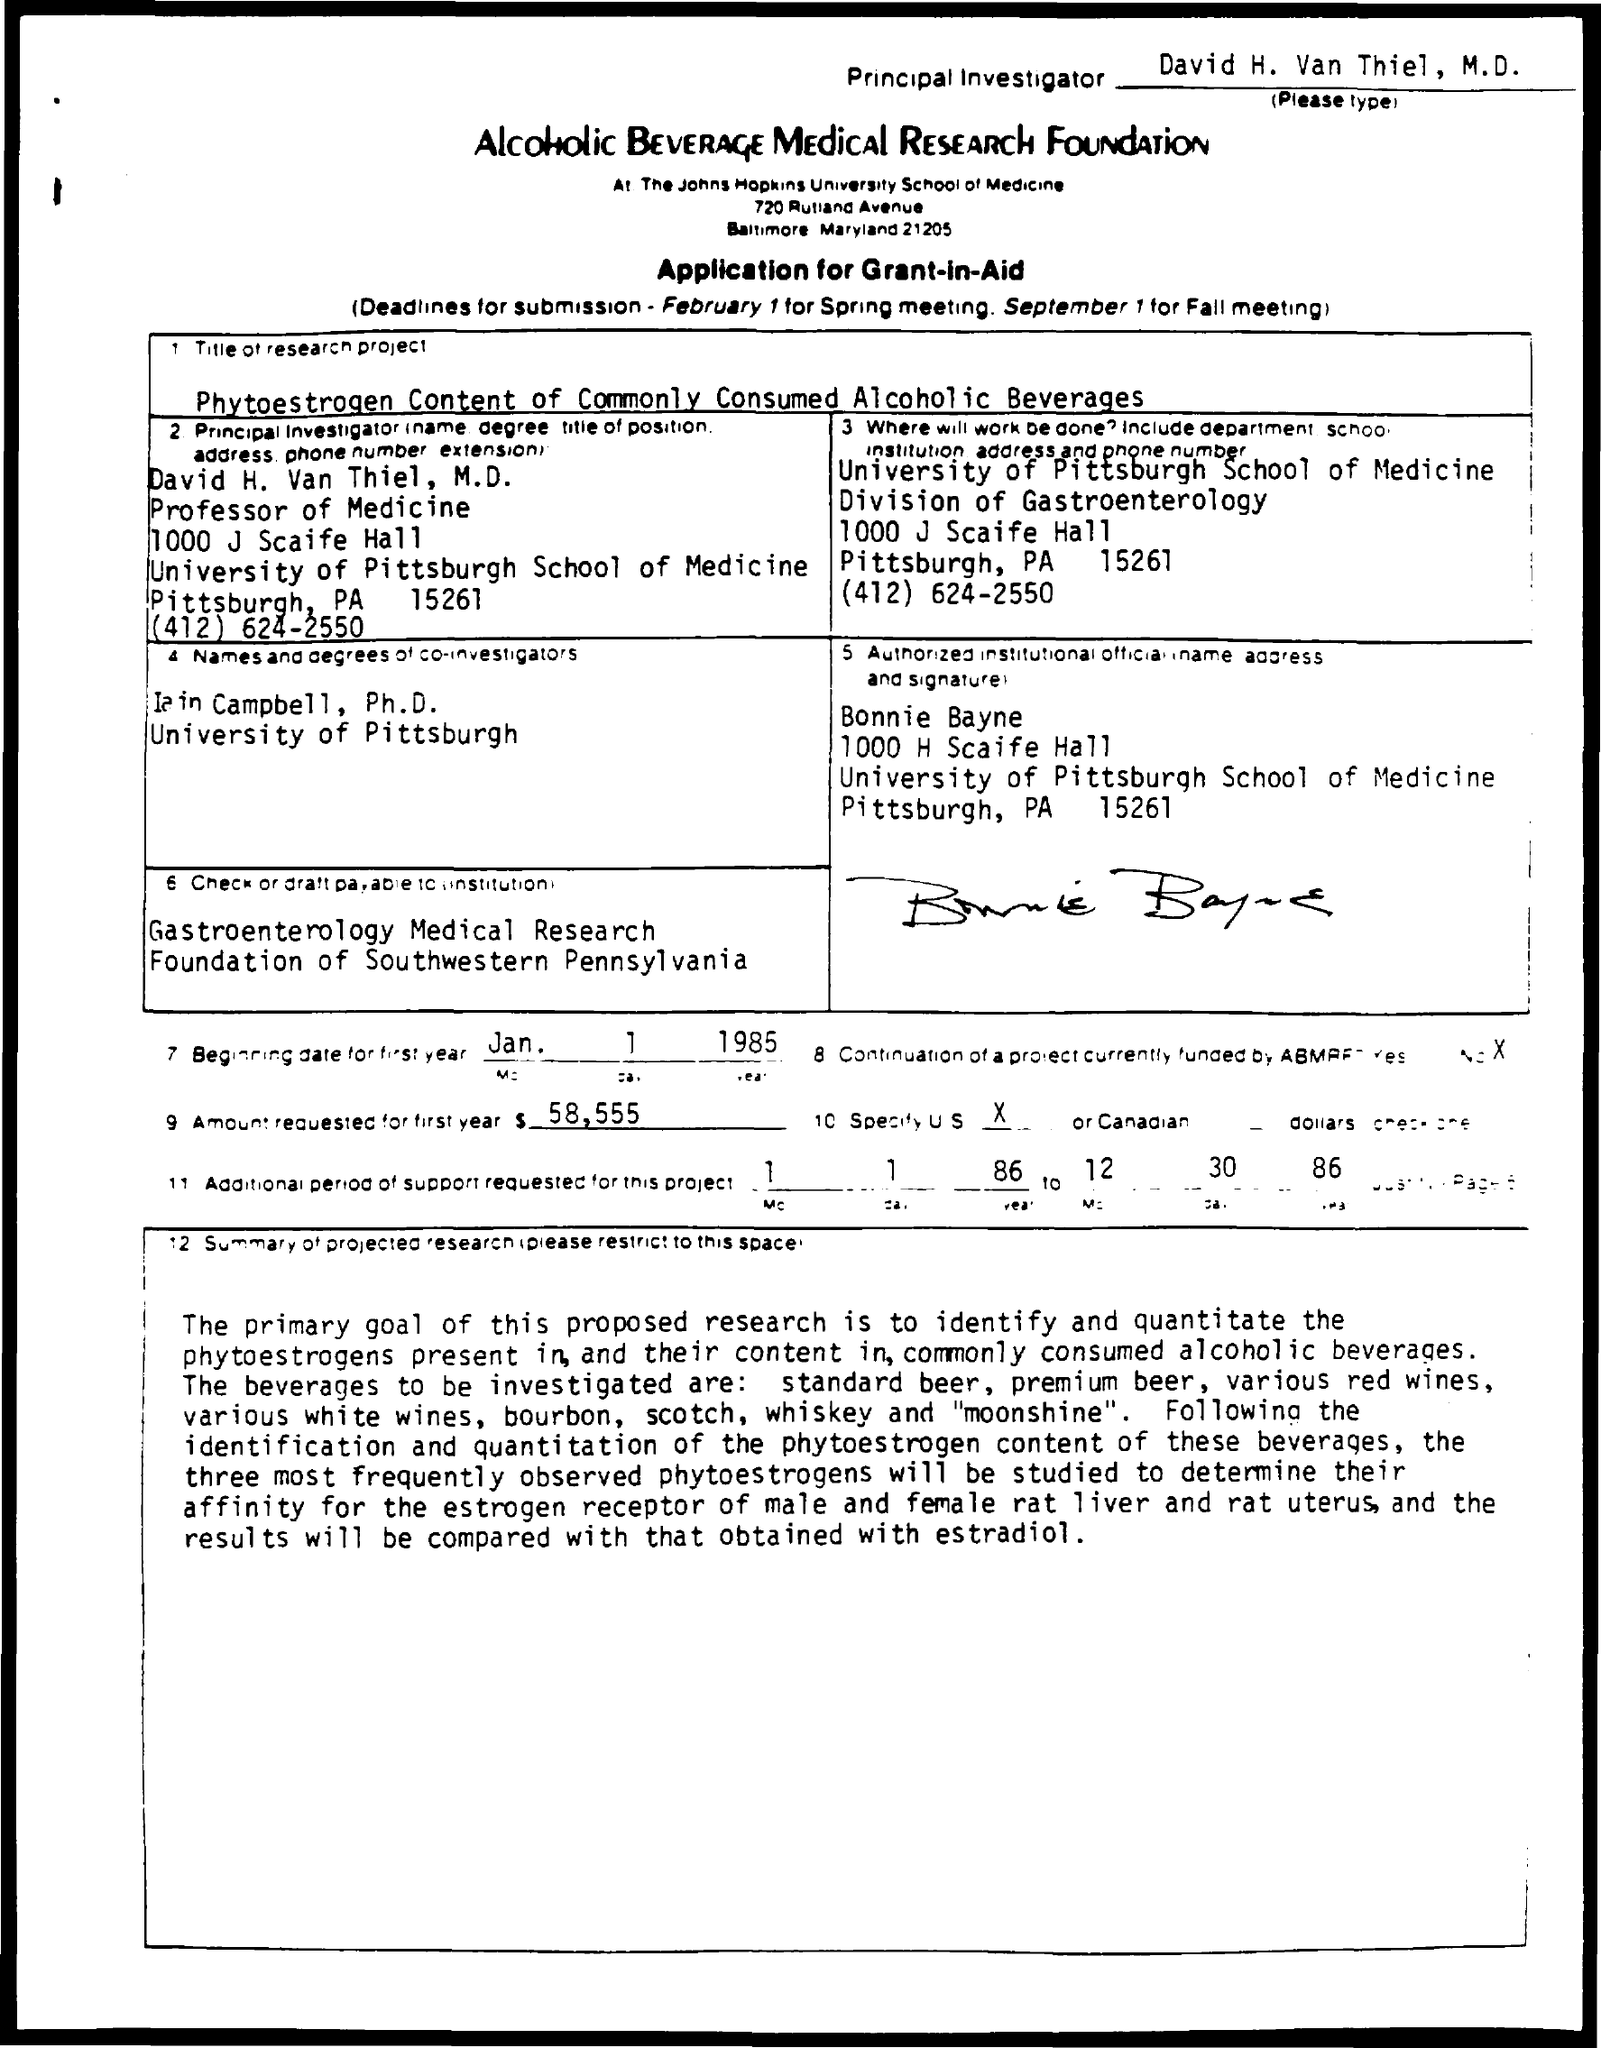Who is the Principal Investigator?
Provide a short and direct response. David H. Van Thiel, M.D. What is the beginning date for first year?
Keep it short and to the point. Jan 1 1985. What is the amount requested for first year?
Offer a terse response. $ 58,555. 